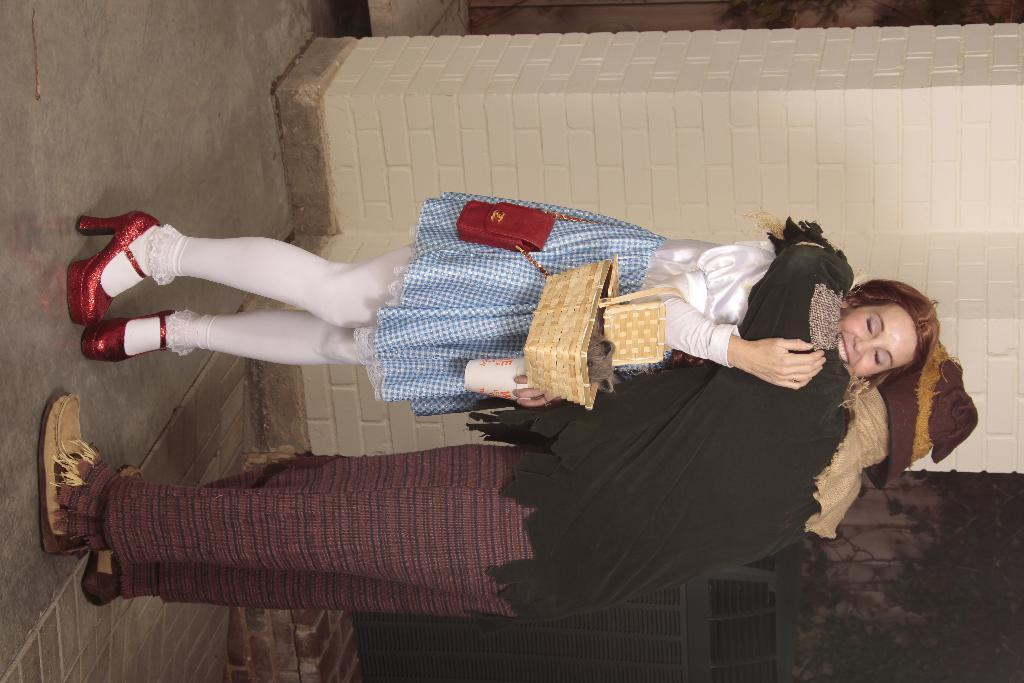What are the two persons in the image doing? The two persons in the image are standing and hugging each other. What is the woman holding in the image? The woman is holding a basket. What is the expression on the woman's face? The woman is smiling. What can be seen in the background of the image? There is a brick wall in the background of the image. What type of zipper is visible on the woman's clothing in the image? There is no zipper visible on the woman's clothing in the image. Who is the representative of the group in the image? The image does not depict a group, and there is no indication of a representative. 